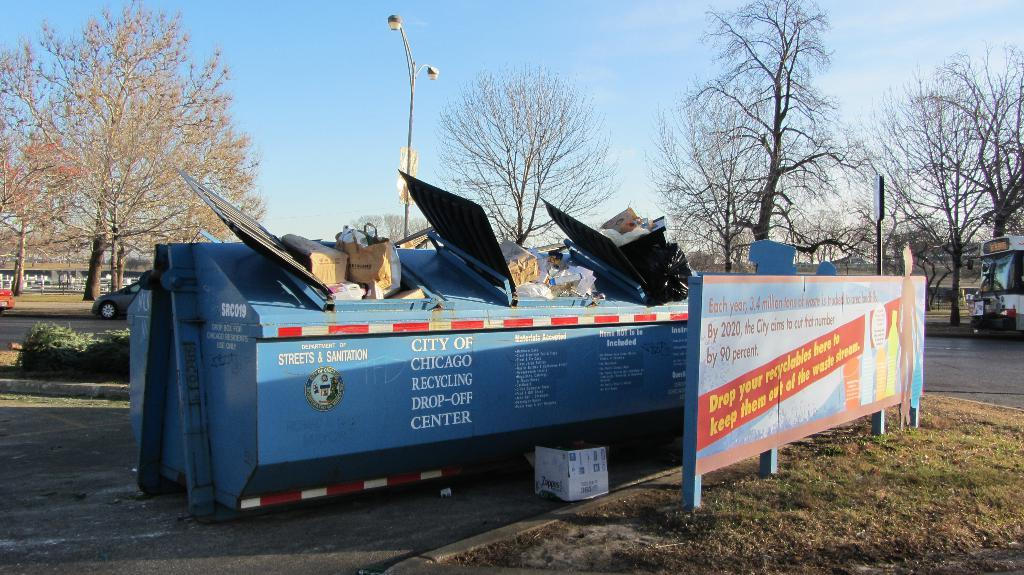<image>
Give a short and clear explanation of the subsequent image. A large blue bin that says to Drop Your Recycleables here. 